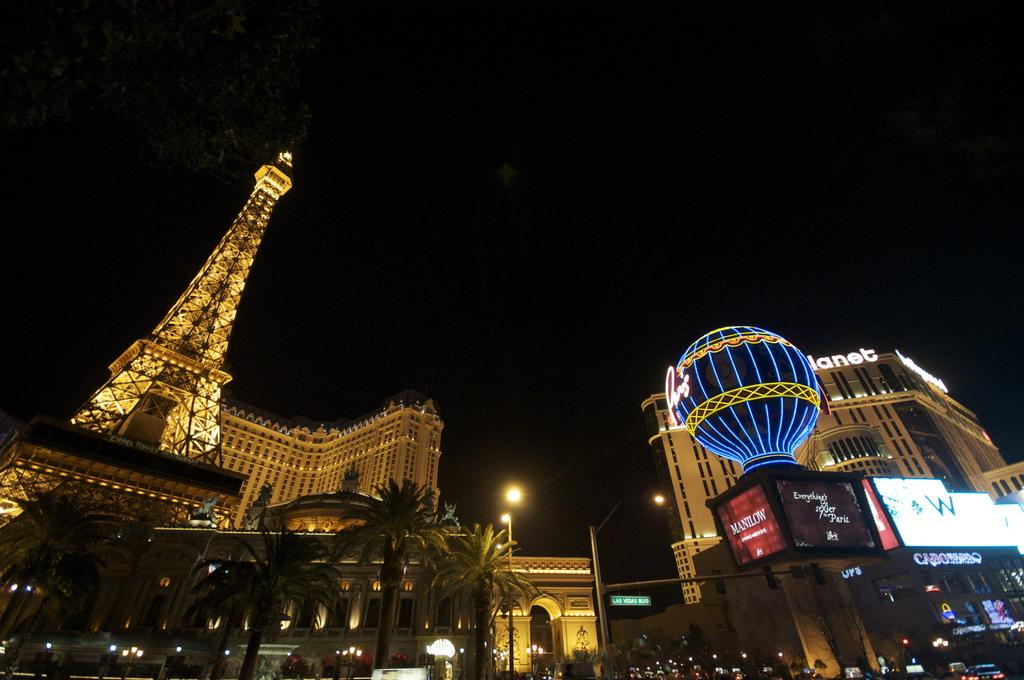What type of structures can be seen in the image? There are buildings in the image. What other natural elements are present in the image? There are trees in the image. What mode of transportation can be seen on the road? There are vehicles on the road in the image. What type of lighting is present in the image? There are lights on the poles in the image. How is the traffic regulated in the image? There is a traffic signal in the image. What type of guitar can be seen hanging on the tree in the image? There is no guitar present in the image; it features buildings, trees, vehicles, lights, and a traffic signal. How many rings are visible on the traffic signal in the image? The traffic signal in the image does not have rings; it has lights that indicate the traffic flow. 